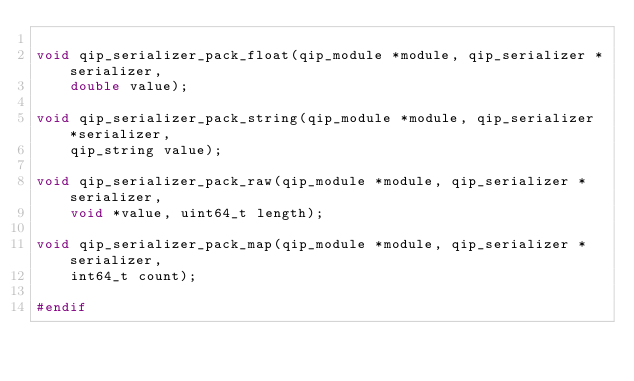<code> <loc_0><loc_0><loc_500><loc_500><_C_>
void qip_serializer_pack_float(qip_module *module, qip_serializer *serializer,
    double value);

void qip_serializer_pack_string(qip_module *module, qip_serializer *serializer,
    qip_string value);

void qip_serializer_pack_raw(qip_module *module, qip_serializer *serializer,
    void *value, uint64_t length);

void qip_serializer_pack_map(qip_module *module, qip_serializer *serializer,
    int64_t count);

#endif
</code> 